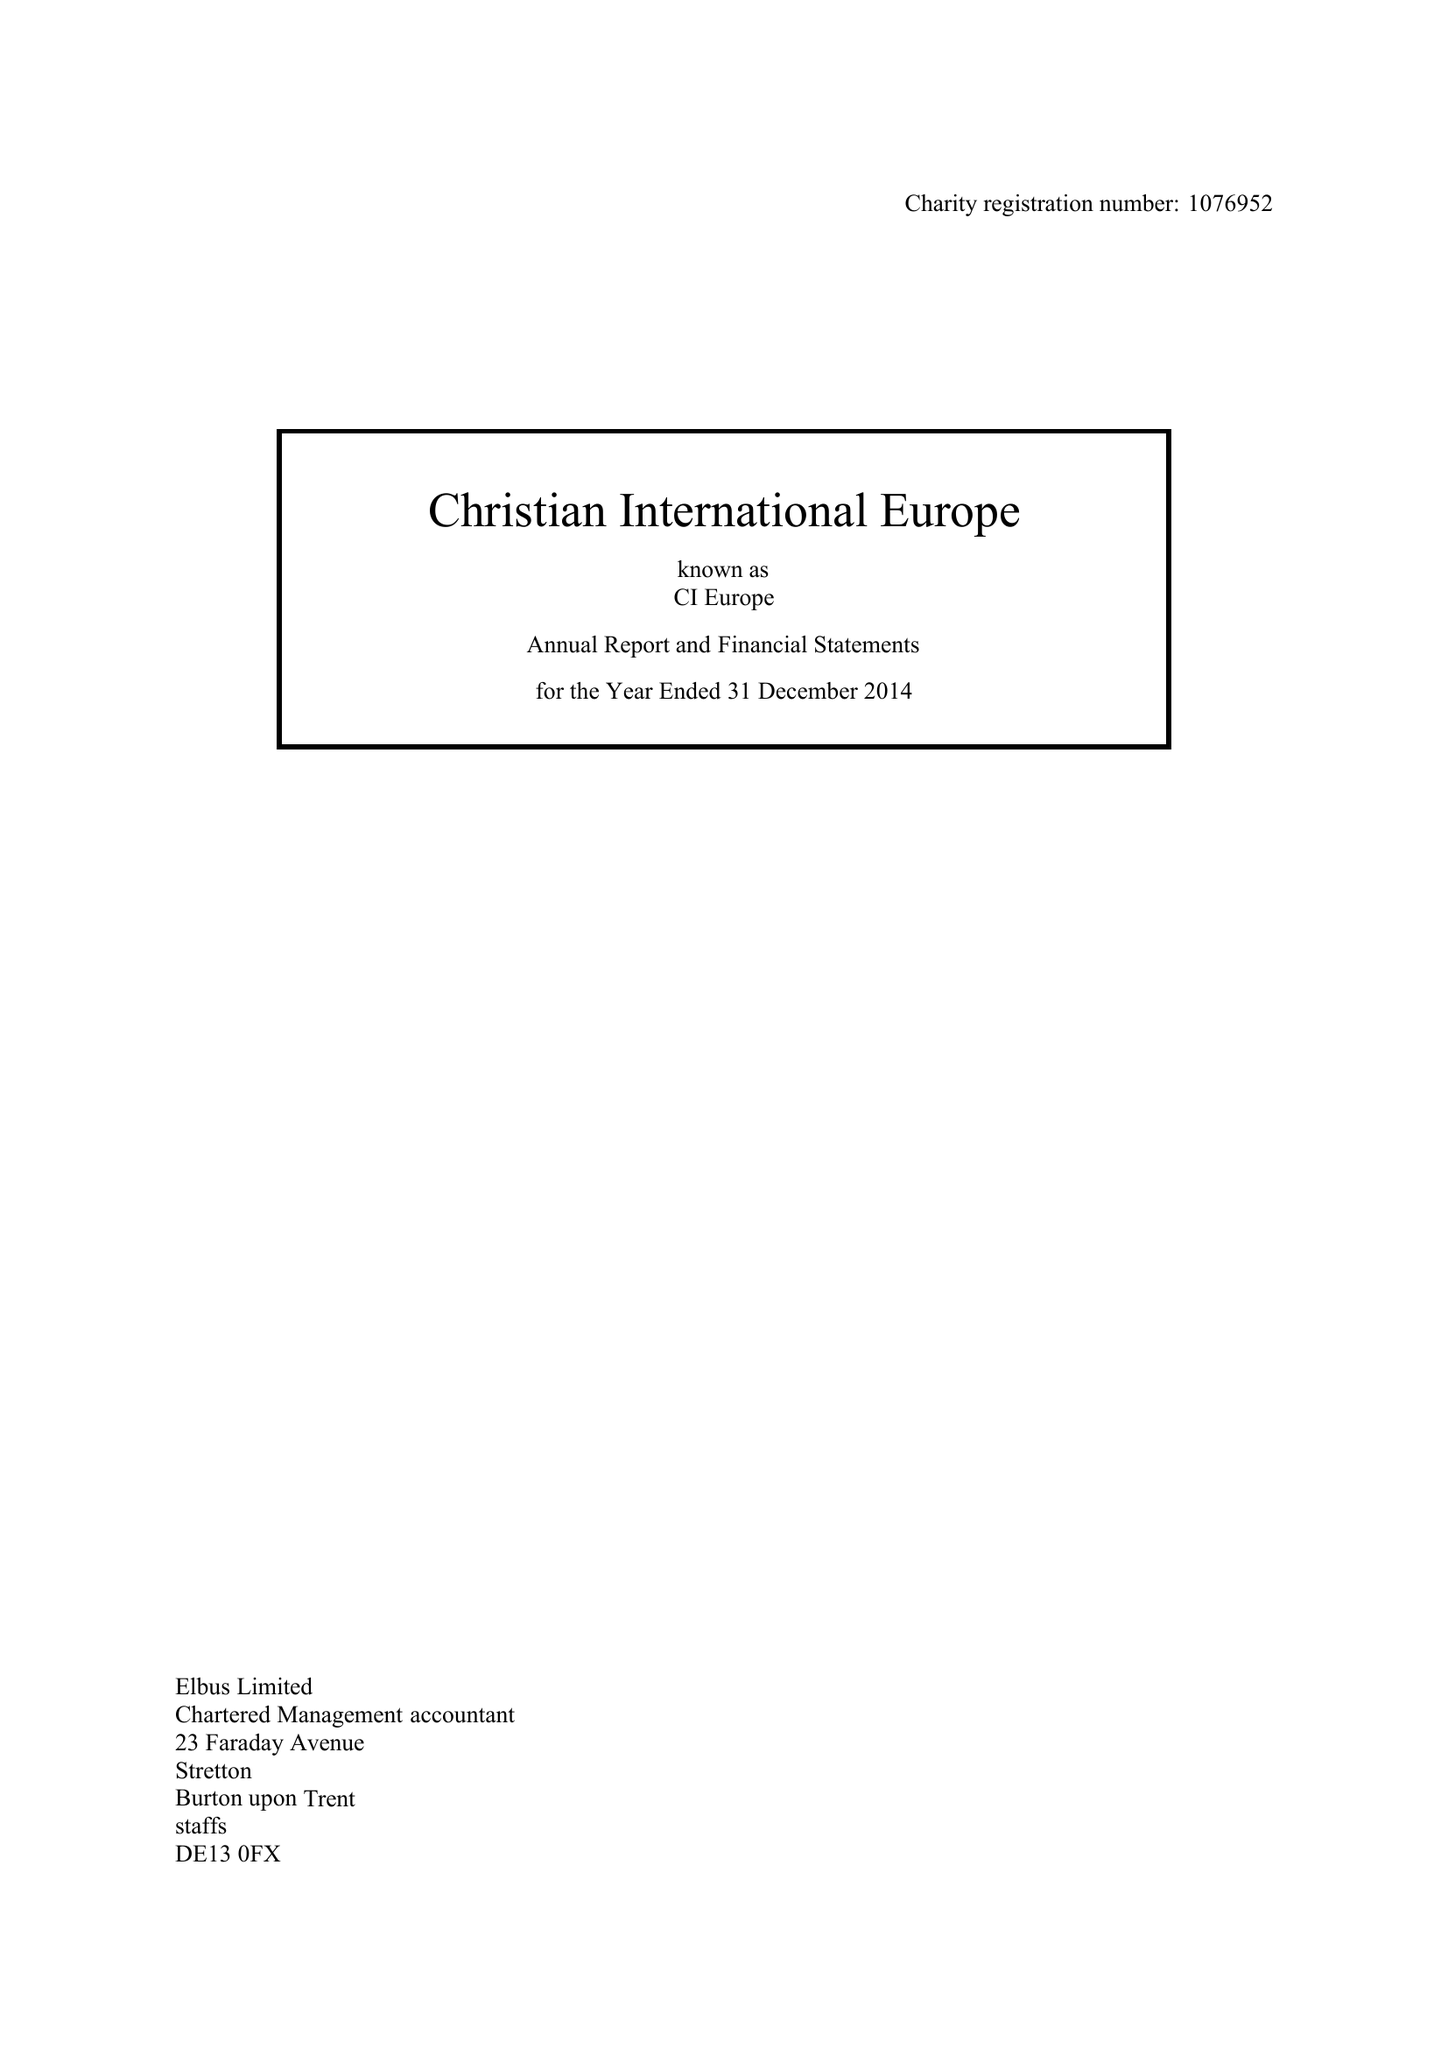What is the value for the address__postcode?
Answer the question using a single word or phrase. SL4 1LA 